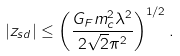Convert formula to latex. <formula><loc_0><loc_0><loc_500><loc_500>| z _ { s d } | \leq \left ( \frac { G _ { F } m _ { c } ^ { 2 } \lambda ^ { 2 } } { 2 \sqrt { 2 } \pi ^ { 2 } } \right ) ^ { 1 / 2 } .</formula> 